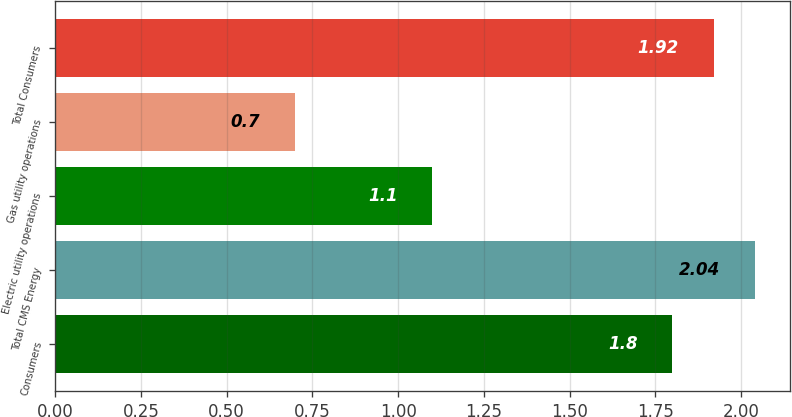Convert chart to OTSL. <chart><loc_0><loc_0><loc_500><loc_500><bar_chart><fcel>Consumers<fcel>Total CMS Energy<fcel>Electric utility operations<fcel>Gas utility operations<fcel>Total Consumers<nl><fcel>1.8<fcel>2.04<fcel>1.1<fcel>0.7<fcel>1.92<nl></chart> 